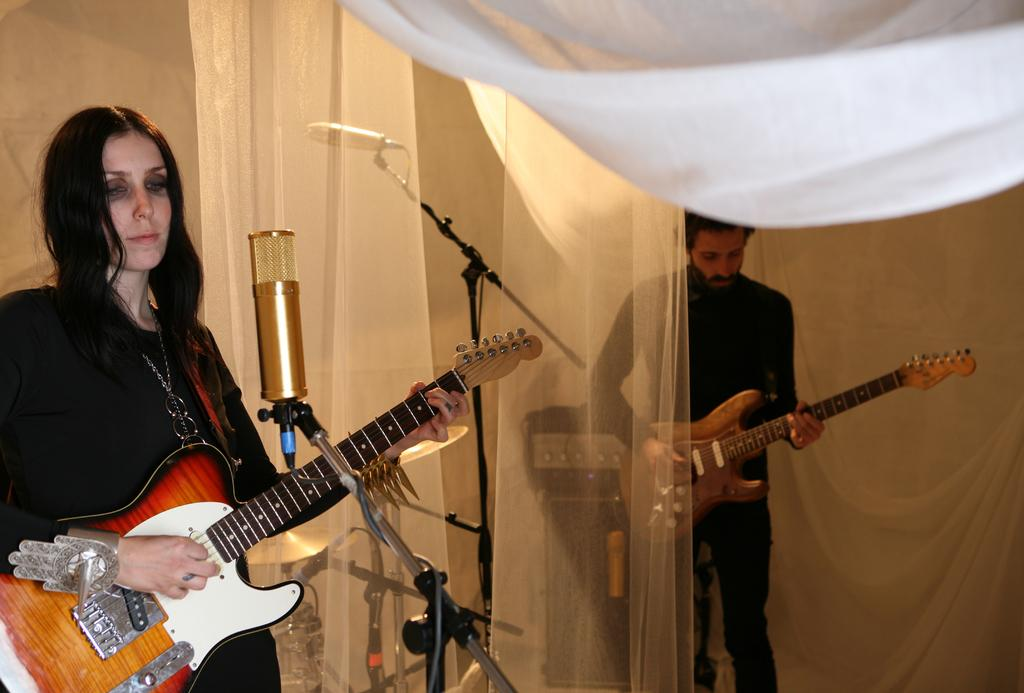How many people are in the image? There are two people in the image. What are the people wearing? Both people are wearing black dresses. What are the people doing in the image? The people are playing the guitar. Can you describe the position of one of the people? One person is standing in front of a mic. What is between the two people? There is a white curtain between the two people. What is the weather like in the image? The provided facts do not mention the weather, so we cannot determine the weather from the image. What are the people talking about in the image? The provided facts do not mention any conversation or topic of discussion, so we cannot determine what the people are talking about. 